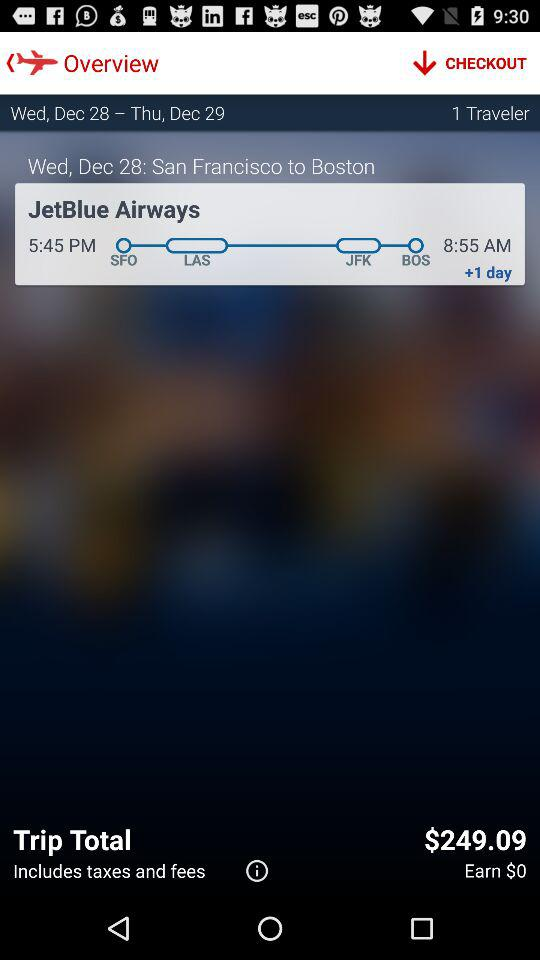What is the date of the journey? The date is Wednesday, December 28. 